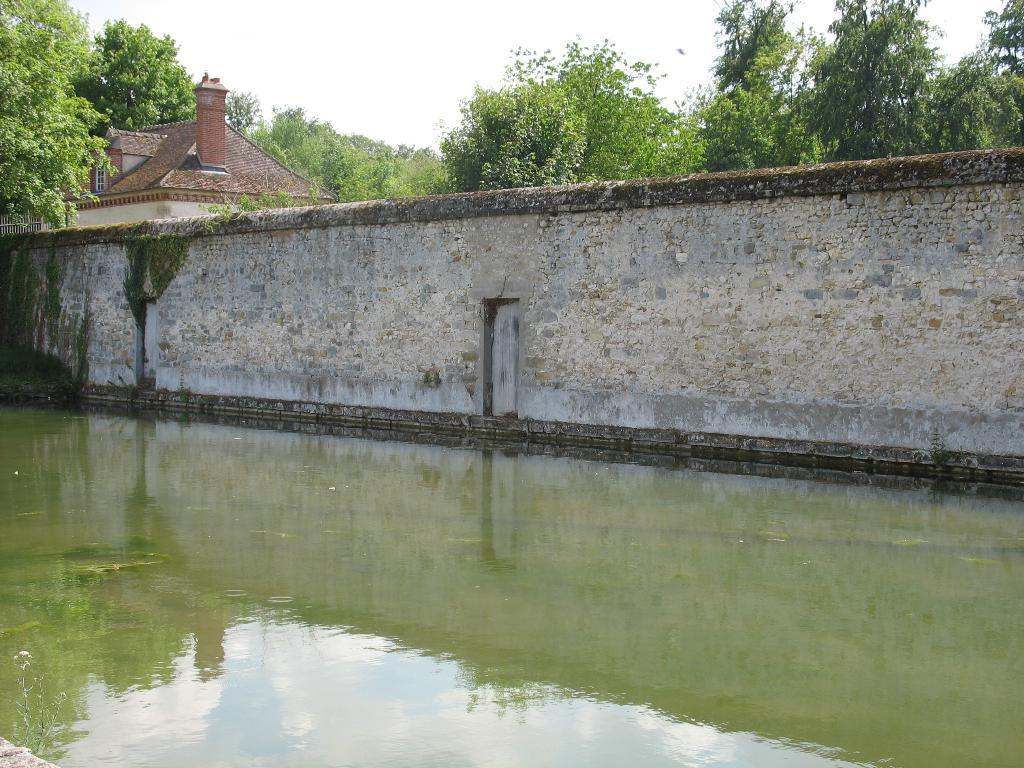What is in the foreground of the image? In the foreground of the image, there is water, a wall fence, a house, and trees. Can you describe the sky in the image? The sky is visible at the top of the image, and it was taken during the day. What type of vegetation can be seen in the foreground of the image? Trees are present in the foreground of the image. Can you tell me how many quartz rocks are visible in the image? There is no mention of quartz rocks in the image, so it is not possible to determine their presence or quantity. Is there a ladybug crawling on the wall fence in the image? There is no mention of a ladybug in the image, so it is not possible to determine its presence. 